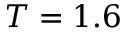Convert formula to latex. <formula><loc_0><loc_0><loc_500><loc_500>T = 1 . 6</formula> 